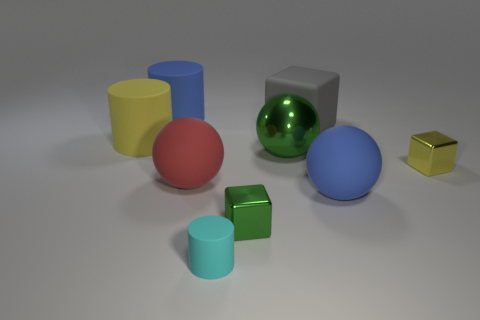Is the number of small cyan rubber cylinders that are behind the big red matte sphere the same as the number of large red rubber balls in front of the tiny cylinder?
Make the answer very short. Yes. The cyan object that is the same shape as the yellow rubber thing is what size?
Your answer should be very brief. Small. There is a matte object that is both in front of the yellow block and left of the tiny cyan rubber thing; how big is it?
Give a very brief answer. Large. There is a large red thing; are there any yellow things to the left of it?
Ensure brevity in your answer.  Yes. What number of objects are small metallic objects that are to the left of the big gray cube or large rubber blocks?
Your answer should be compact. 2. How many tiny cyan rubber cylinders are on the left side of the metal cube behind the tiny green metal cube?
Your response must be concise. 1. Are there fewer yellow metallic blocks behind the large green object than red things that are on the right side of the large cube?
Keep it short and to the point. No. What is the shape of the large blue object that is to the right of the tiny metallic block on the left side of the big blue rubber ball?
Your answer should be very brief. Sphere. How many other objects are there of the same material as the cyan cylinder?
Your answer should be very brief. 5. Is there anything else that has the same size as the yellow metal cube?
Provide a succinct answer. Yes. 